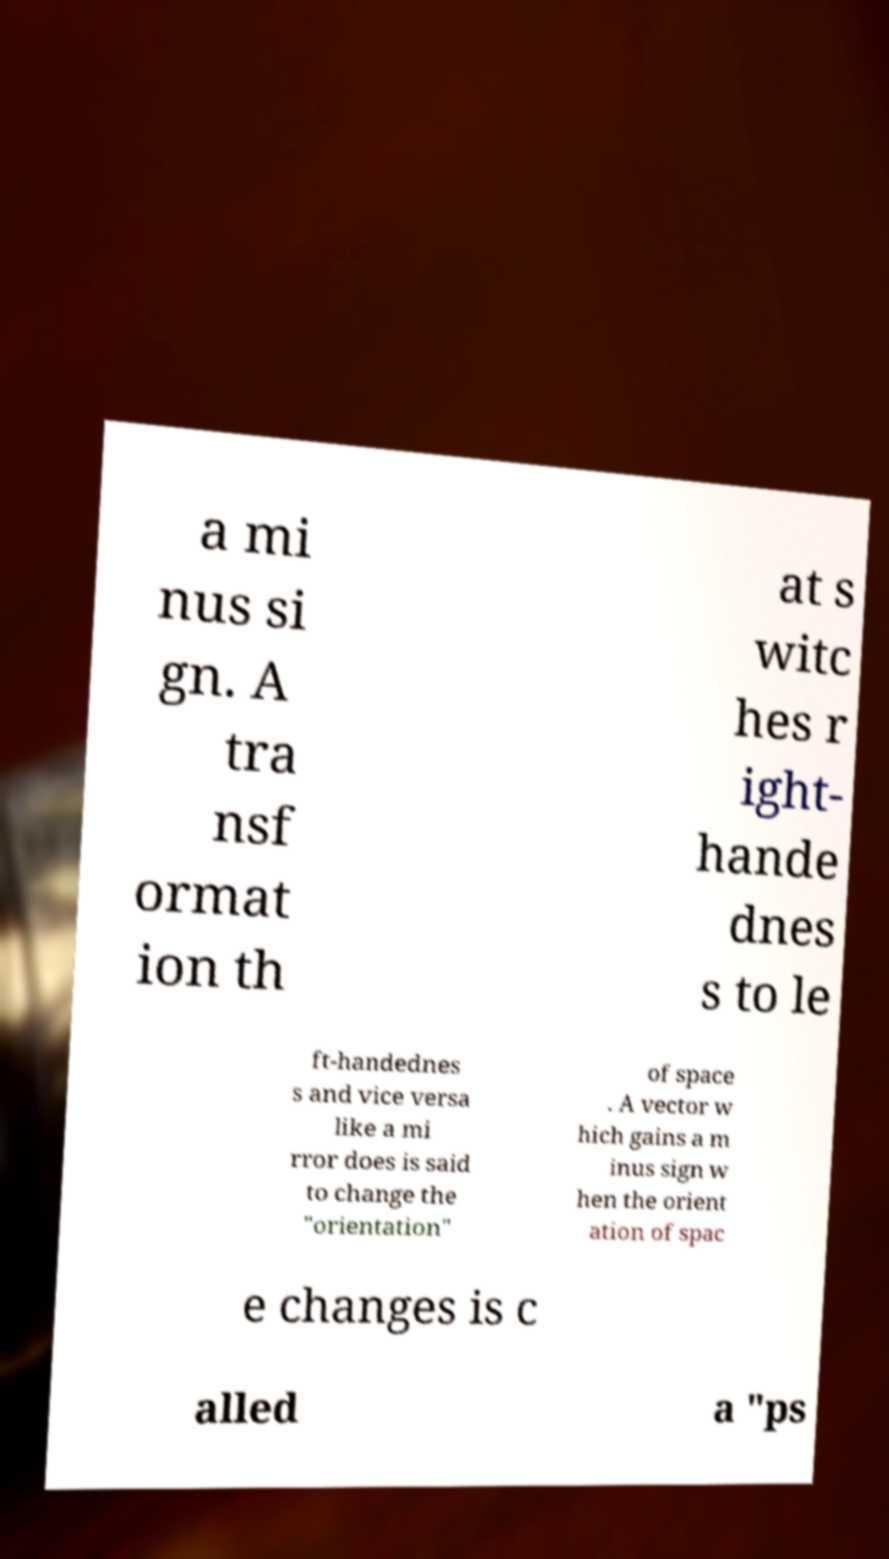For documentation purposes, I need the text within this image transcribed. Could you provide that? a mi nus si gn. A tra nsf ormat ion th at s witc hes r ight- hande dnes s to le ft-handednes s and vice versa like a mi rror does is said to change the "orientation" of space . A vector w hich gains a m inus sign w hen the orient ation of spac e changes is c alled a "ps 